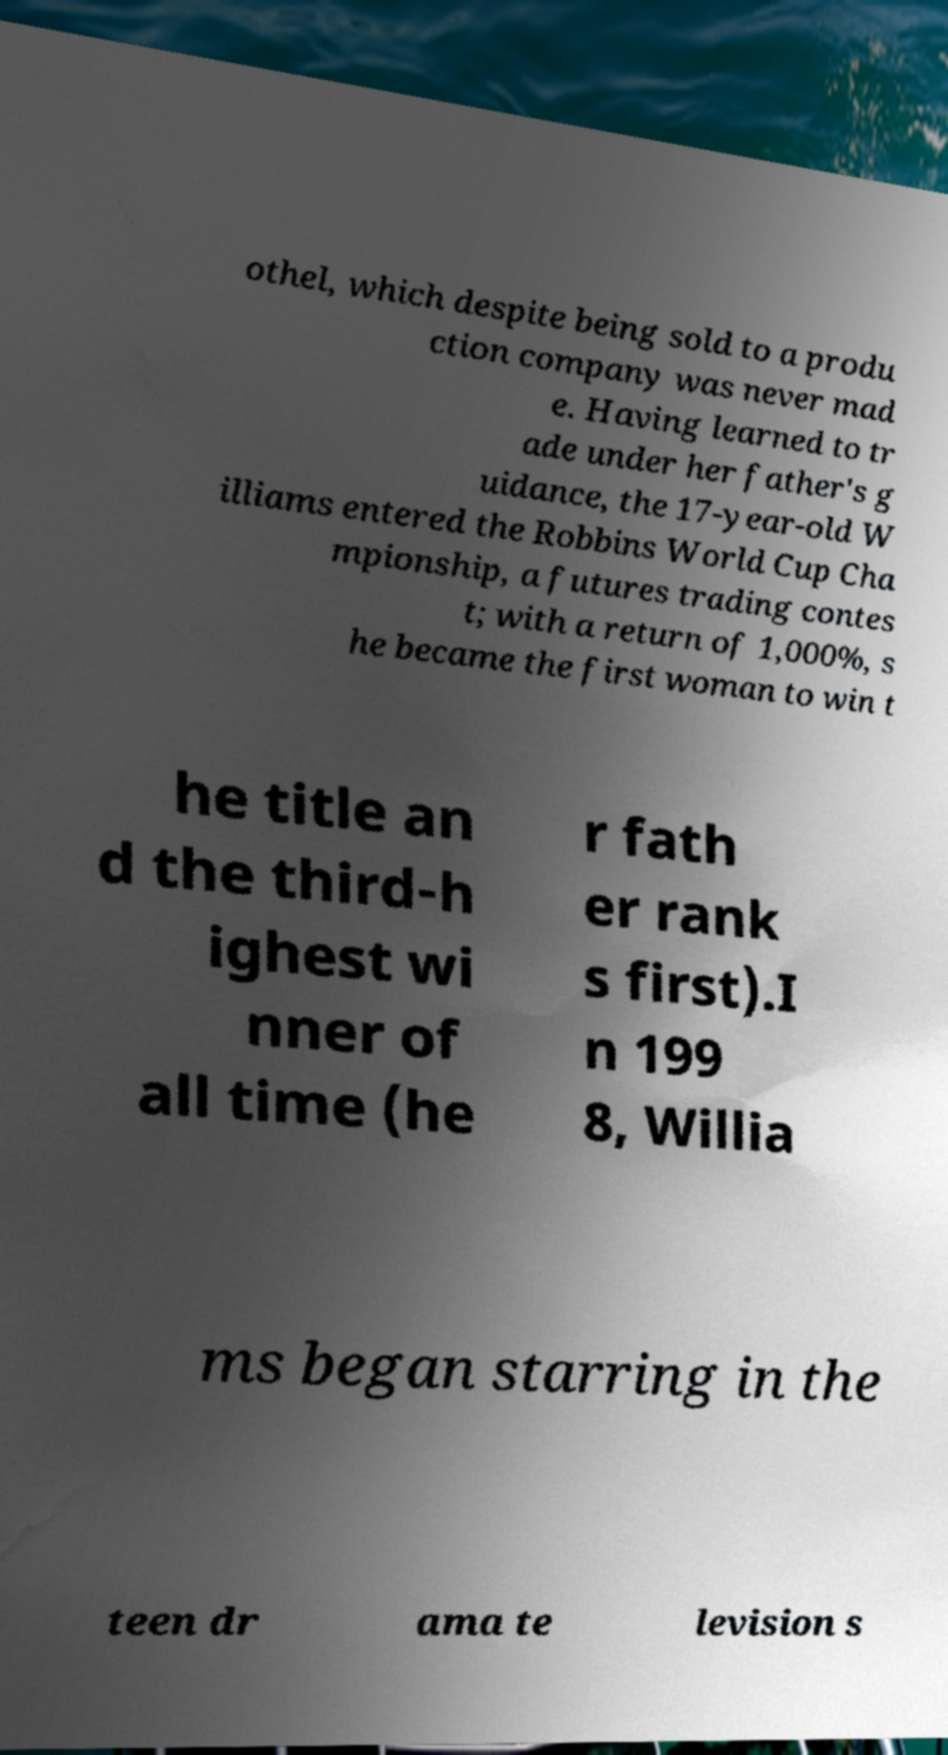Can you accurately transcribe the text from the provided image for me? othel, which despite being sold to a produ ction company was never mad e. Having learned to tr ade under her father's g uidance, the 17-year-old W illiams entered the Robbins World Cup Cha mpionship, a futures trading contes t; with a return of 1,000%, s he became the first woman to win t he title an d the third-h ighest wi nner of all time (he r fath er rank s first).I n 199 8, Willia ms began starring in the teen dr ama te levision s 